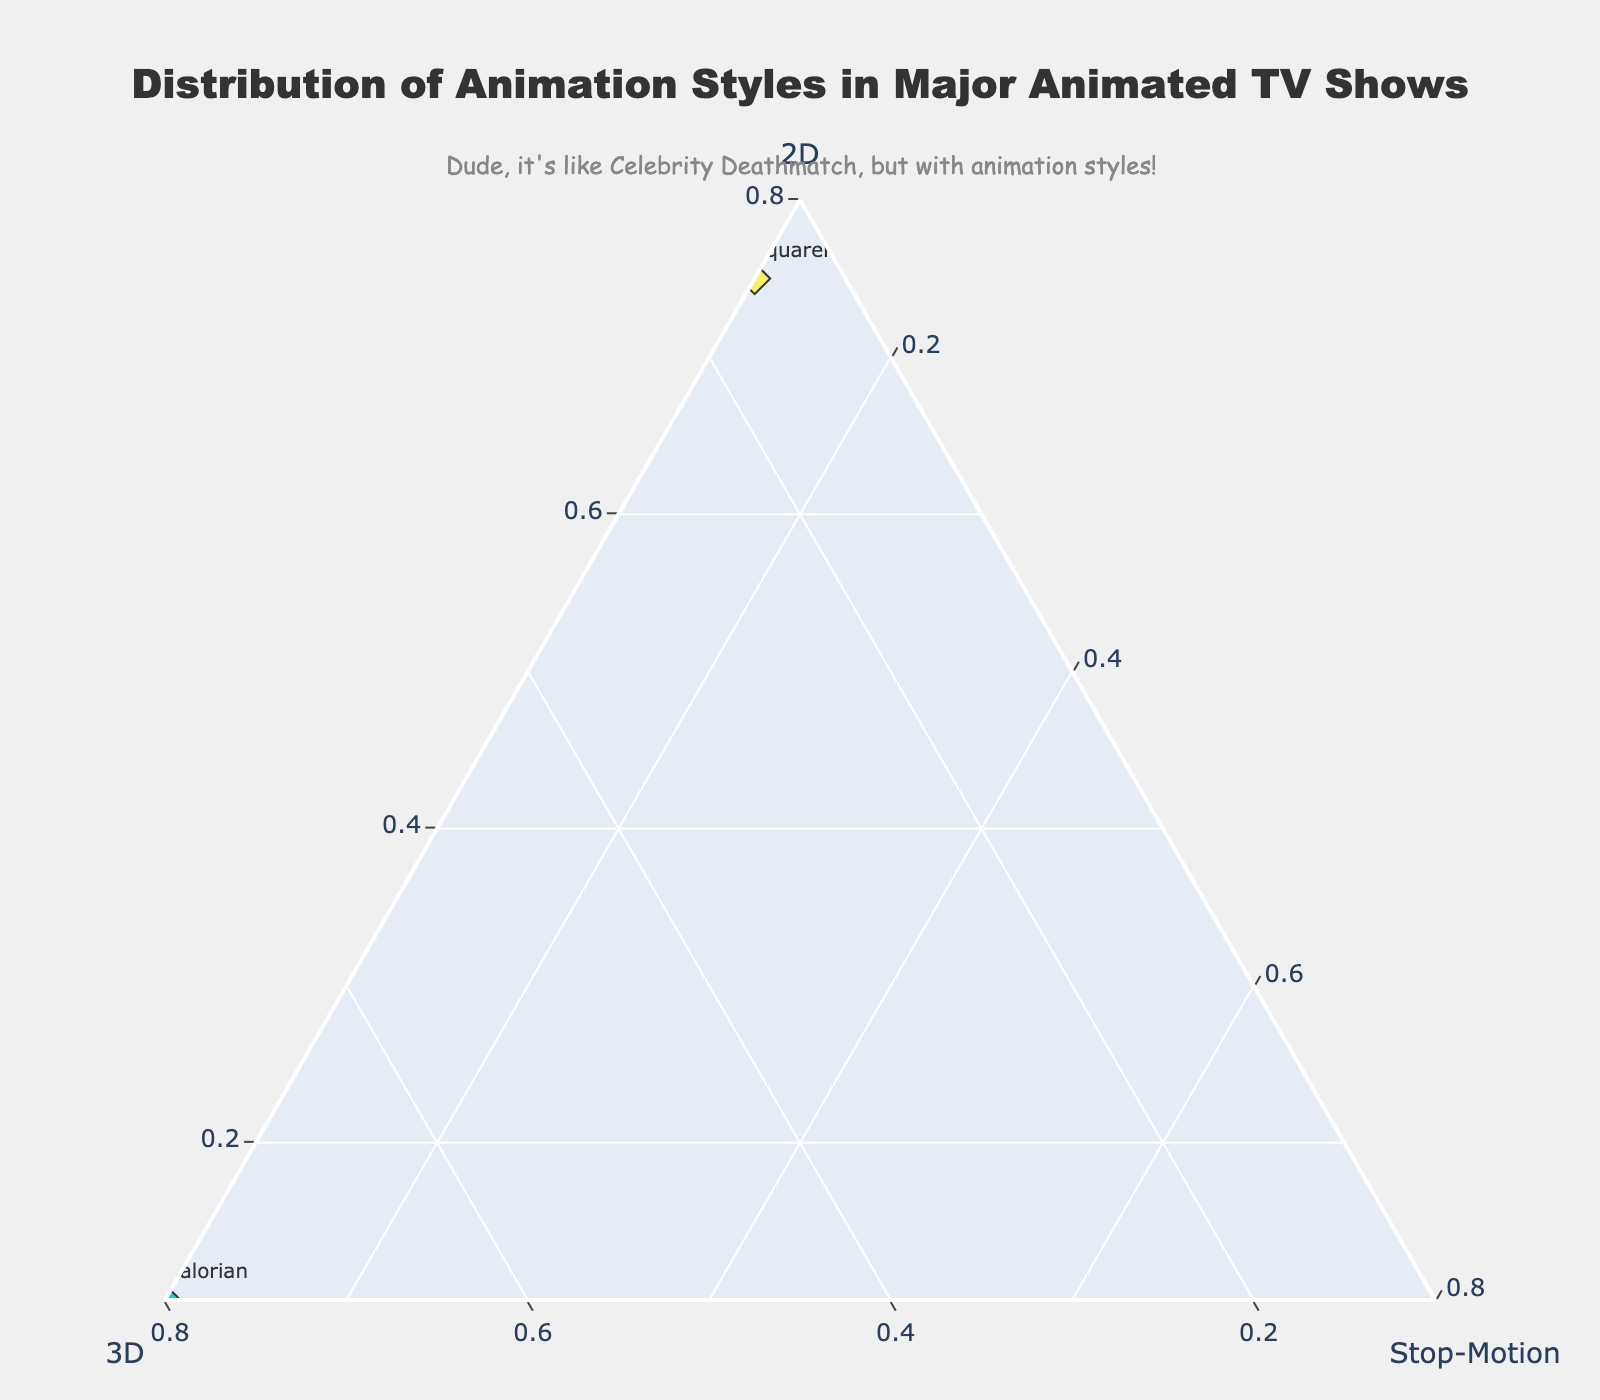What TV show primarily utilizes Stop-Motion animation? The show "Robot Chicken" has 0.8 (80%) Stop-Motion, and "Wallace and Gromit" has 0.85 (85%) Stop-Motion.
Answer: "Robot Chicken" and "Wallace and Gromit" What's the most common animation style among "The Simpsons," "Futurama," and "Rick and Morty"? By looking at the plot, we see that "The Simpsons," "Futurama," and "Rick and Morty" have the highest proportions of 2D animation style.
Answer: 2D Which show has the highest proportion of 3D animation? "The Mandalorian" has the highest 3D proportion at 0.8 (80%).
Answer: "The Mandalorian" Which show uses a combination of all three animation styles? "SpongeBob SquarePants" utilizes 2D (0.75), 3D (0.15), and Stop-Motion (0.1) to some extent.
Answer: "SpongeBob SquarePants" Between "South Park" and "Family Guy," which show is closer to using only one animation style? Both "South Park" and "Family Guy" predominantly use 2D animation. However, "South Park" has no 3D or Stop-Motion, whereas "Family Guy" has a small proportion of 3D.
Answer: "South Park" What's the total proportion of non-stop-motion styles in "BoJack Horseman"? For "BoJack Horseman": 2D (0.9) + 3D (0.1) = 1.0
Answer: 1.0 Compare the use of 2D animation between "The Simpsons" and "Rick and Morty." Which show has a higher proportion? "The Simpsons" has a proportion of 2D at 0.9, while "Rick and Morty" has it at 0.85.
Answer: "The Simpsons" Which animated show uses the least amount of 2D animation? "Wallace and Gromit" has the least 2D animation at 0.1.
Answer: "Wallace and Gromit" How many shows have a 2D animation proportion greater than or equal to 0.75? The shows are "The Simpsons," "Futurama," "Rick and Morty," "South Park," "Family Guy," "BoJack Horseman," and "SpongeBob SquarePants." This totals seven shows.
Answer: 7 